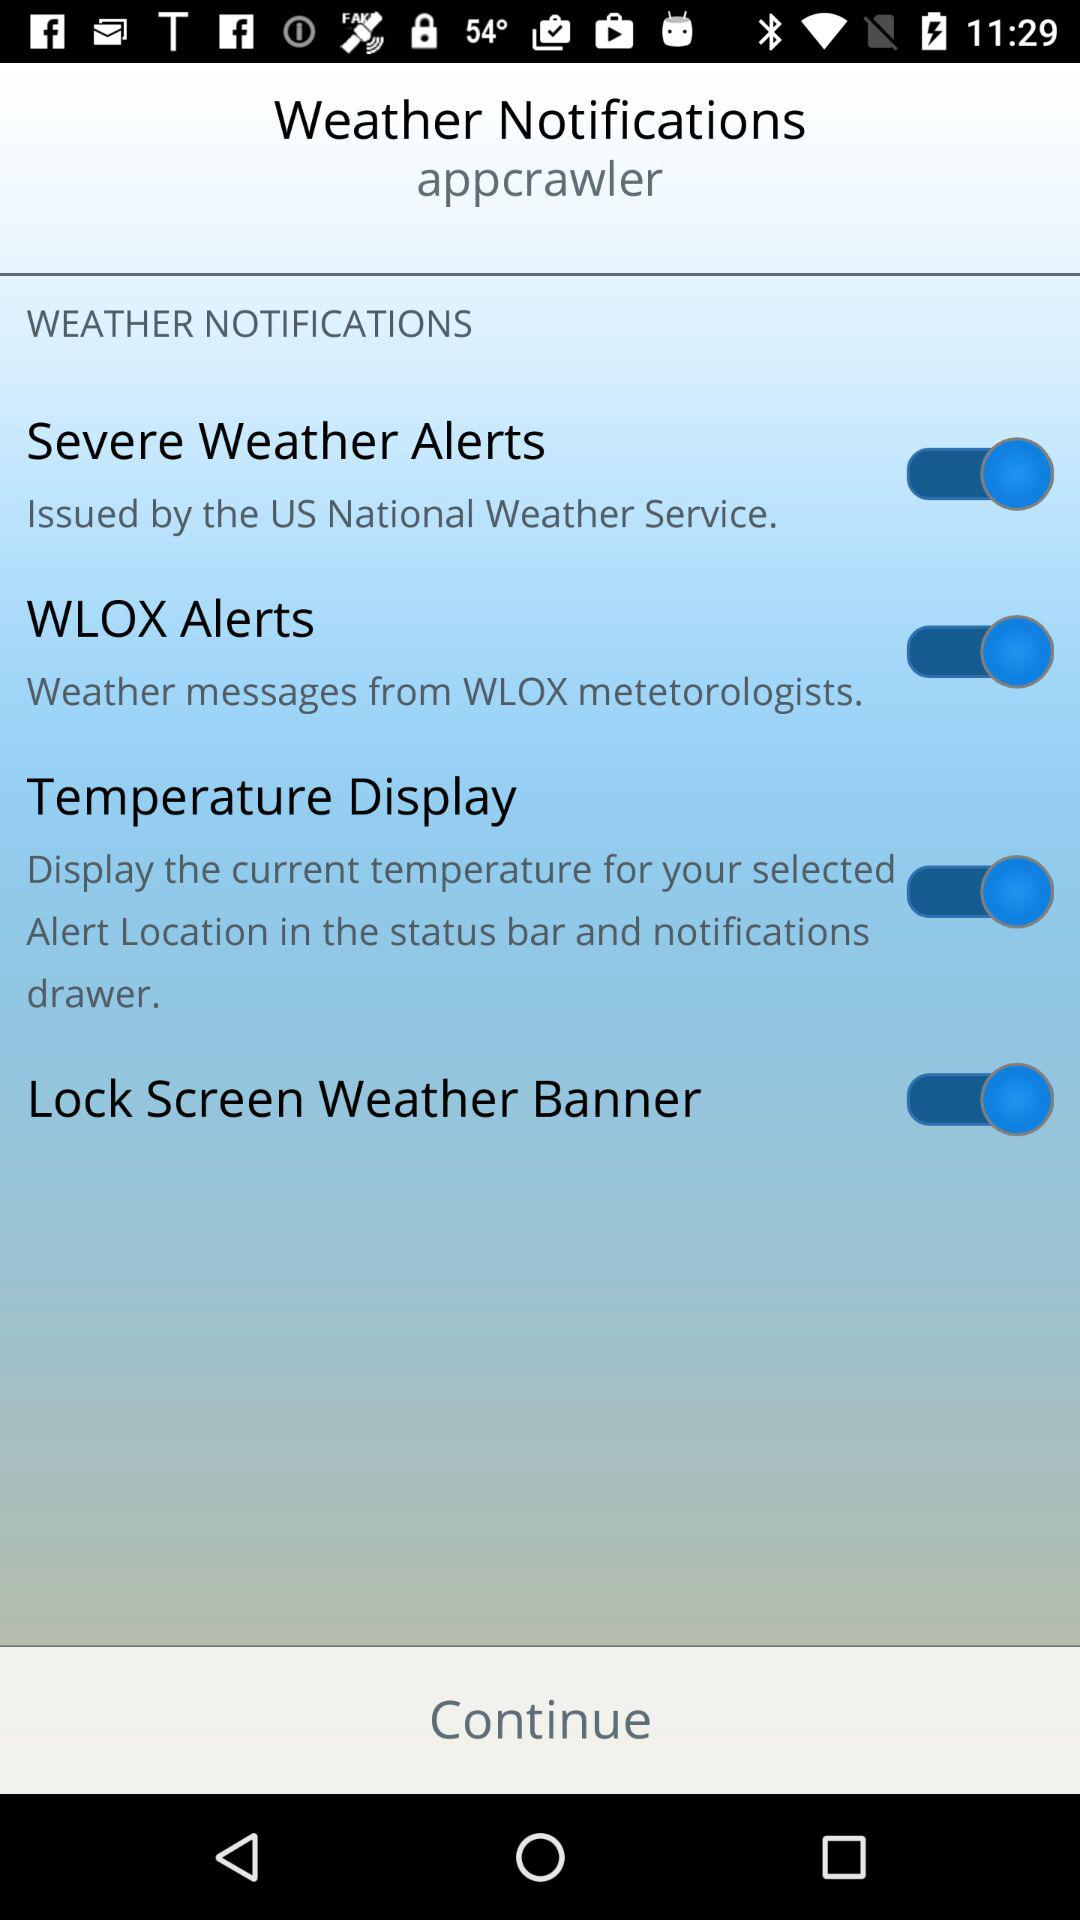What is the user name? The user name is "appcrawler". 